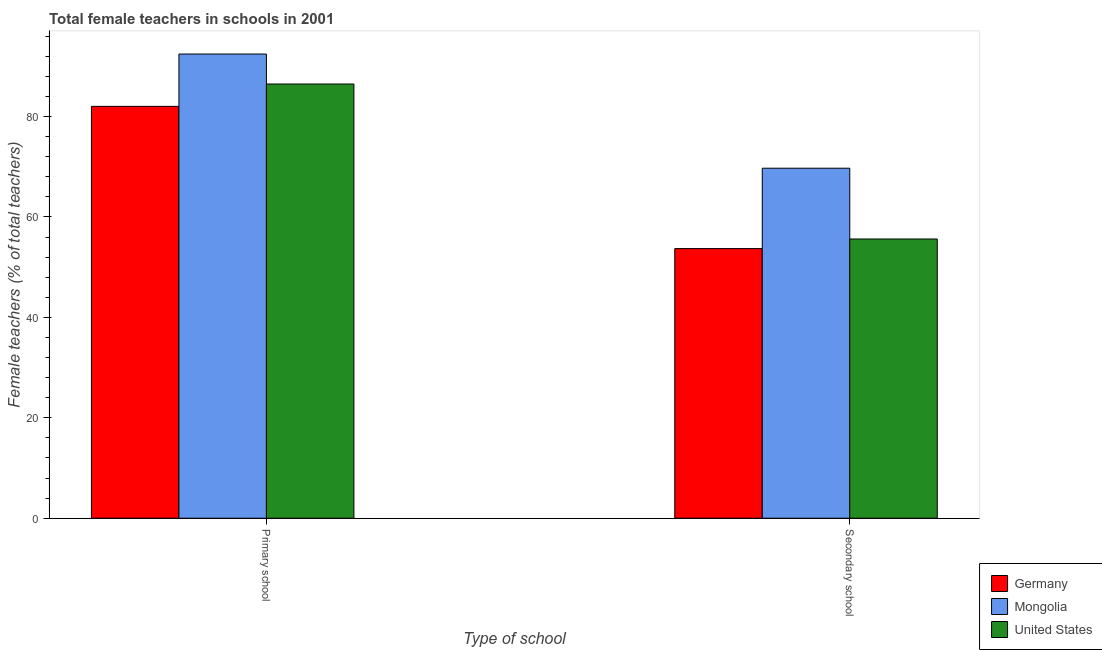How many groups of bars are there?
Your answer should be compact. 2. Are the number of bars per tick equal to the number of legend labels?
Offer a terse response. Yes. What is the label of the 1st group of bars from the left?
Provide a succinct answer. Primary school. What is the percentage of female teachers in secondary schools in Germany?
Provide a succinct answer. 53.71. Across all countries, what is the maximum percentage of female teachers in primary schools?
Your answer should be very brief. 92.46. Across all countries, what is the minimum percentage of female teachers in secondary schools?
Make the answer very short. 53.71. In which country was the percentage of female teachers in primary schools maximum?
Your response must be concise. Mongolia. What is the total percentage of female teachers in secondary schools in the graph?
Your response must be concise. 179.04. What is the difference between the percentage of female teachers in primary schools in Mongolia and that in United States?
Your answer should be very brief. 5.97. What is the difference between the percentage of female teachers in primary schools in United States and the percentage of female teachers in secondary schools in Germany?
Give a very brief answer. 32.78. What is the average percentage of female teachers in secondary schools per country?
Offer a terse response. 59.68. What is the difference between the percentage of female teachers in secondary schools and percentage of female teachers in primary schools in United States?
Give a very brief answer. -30.87. In how many countries, is the percentage of female teachers in primary schools greater than 32 %?
Give a very brief answer. 3. What is the ratio of the percentage of female teachers in secondary schools in Germany to that in United States?
Ensure brevity in your answer.  0.97. In how many countries, is the percentage of female teachers in secondary schools greater than the average percentage of female teachers in secondary schools taken over all countries?
Give a very brief answer. 1. What does the 2nd bar from the left in Secondary school represents?
Provide a short and direct response. Mongolia. What does the 3rd bar from the right in Primary school represents?
Ensure brevity in your answer.  Germany. Are all the bars in the graph horizontal?
Your answer should be very brief. No. Where does the legend appear in the graph?
Your answer should be compact. Bottom right. How are the legend labels stacked?
Make the answer very short. Vertical. What is the title of the graph?
Offer a terse response. Total female teachers in schools in 2001. What is the label or title of the X-axis?
Offer a very short reply. Type of school. What is the label or title of the Y-axis?
Your answer should be compact. Female teachers (% of total teachers). What is the Female teachers (% of total teachers) in Germany in Primary school?
Ensure brevity in your answer.  82.03. What is the Female teachers (% of total teachers) in Mongolia in Primary school?
Your response must be concise. 92.46. What is the Female teachers (% of total teachers) of United States in Primary school?
Provide a short and direct response. 86.49. What is the Female teachers (% of total teachers) in Germany in Secondary school?
Your response must be concise. 53.71. What is the Female teachers (% of total teachers) in Mongolia in Secondary school?
Provide a succinct answer. 69.71. What is the Female teachers (% of total teachers) of United States in Secondary school?
Offer a terse response. 55.62. Across all Type of school, what is the maximum Female teachers (% of total teachers) of Germany?
Offer a terse response. 82.03. Across all Type of school, what is the maximum Female teachers (% of total teachers) in Mongolia?
Offer a terse response. 92.46. Across all Type of school, what is the maximum Female teachers (% of total teachers) of United States?
Keep it short and to the point. 86.49. Across all Type of school, what is the minimum Female teachers (% of total teachers) of Germany?
Ensure brevity in your answer.  53.71. Across all Type of school, what is the minimum Female teachers (% of total teachers) of Mongolia?
Provide a short and direct response. 69.71. Across all Type of school, what is the minimum Female teachers (% of total teachers) of United States?
Your answer should be very brief. 55.62. What is the total Female teachers (% of total teachers) of Germany in the graph?
Your response must be concise. 135.74. What is the total Female teachers (% of total teachers) of Mongolia in the graph?
Your answer should be very brief. 162.17. What is the total Female teachers (% of total teachers) of United States in the graph?
Offer a very short reply. 142.1. What is the difference between the Female teachers (% of total teachers) in Germany in Primary school and that in Secondary school?
Offer a terse response. 28.33. What is the difference between the Female teachers (% of total teachers) in Mongolia in Primary school and that in Secondary school?
Your answer should be compact. 22.74. What is the difference between the Female teachers (% of total teachers) in United States in Primary school and that in Secondary school?
Offer a very short reply. 30.87. What is the difference between the Female teachers (% of total teachers) in Germany in Primary school and the Female teachers (% of total teachers) in Mongolia in Secondary school?
Offer a very short reply. 12.32. What is the difference between the Female teachers (% of total teachers) in Germany in Primary school and the Female teachers (% of total teachers) in United States in Secondary school?
Offer a terse response. 26.41. What is the difference between the Female teachers (% of total teachers) in Mongolia in Primary school and the Female teachers (% of total teachers) in United States in Secondary school?
Your answer should be very brief. 36.84. What is the average Female teachers (% of total teachers) of Germany per Type of school?
Offer a very short reply. 67.87. What is the average Female teachers (% of total teachers) of Mongolia per Type of school?
Provide a short and direct response. 81.09. What is the average Female teachers (% of total teachers) of United States per Type of school?
Provide a short and direct response. 71.05. What is the difference between the Female teachers (% of total teachers) in Germany and Female teachers (% of total teachers) in Mongolia in Primary school?
Give a very brief answer. -10.42. What is the difference between the Female teachers (% of total teachers) in Germany and Female teachers (% of total teachers) in United States in Primary school?
Your response must be concise. -4.45. What is the difference between the Female teachers (% of total teachers) of Mongolia and Female teachers (% of total teachers) of United States in Primary school?
Make the answer very short. 5.97. What is the difference between the Female teachers (% of total teachers) of Germany and Female teachers (% of total teachers) of Mongolia in Secondary school?
Your answer should be very brief. -16.01. What is the difference between the Female teachers (% of total teachers) in Germany and Female teachers (% of total teachers) in United States in Secondary school?
Make the answer very short. -1.91. What is the difference between the Female teachers (% of total teachers) of Mongolia and Female teachers (% of total teachers) of United States in Secondary school?
Give a very brief answer. 14.1. What is the ratio of the Female teachers (% of total teachers) in Germany in Primary school to that in Secondary school?
Offer a terse response. 1.53. What is the ratio of the Female teachers (% of total teachers) in Mongolia in Primary school to that in Secondary school?
Your response must be concise. 1.33. What is the ratio of the Female teachers (% of total teachers) in United States in Primary school to that in Secondary school?
Keep it short and to the point. 1.55. What is the difference between the highest and the second highest Female teachers (% of total teachers) of Germany?
Your answer should be very brief. 28.33. What is the difference between the highest and the second highest Female teachers (% of total teachers) in Mongolia?
Your answer should be very brief. 22.74. What is the difference between the highest and the second highest Female teachers (% of total teachers) of United States?
Ensure brevity in your answer.  30.87. What is the difference between the highest and the lowest Female teachers (% of total teachers) of Germany?
Ensure brevity in your answer.  28.33. What is the difference between the highest and the lowest Female teachers (% of total teachers) of Mongolia?
Ensure brevity in your answer.  22.74. What is the difference between the highest and the lowest Female teachers (% of total teachers) in United States?
Your answer should be compact. 30.87. 